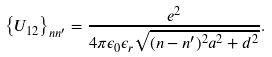<formula> <loc_0><loc_0><loc_500><loc_500>\left \{ U _ { 1 2 } \right \} _ { n n ^ { \prime } } = \frac { e ^ { 2 } } { 4 \pi \epsilon _ { 0 } \epsilon _ { r } \sqrt { ( n - n ^ { \prime } ) ^ { 2 } a ^ { 2 } + d ^ { 2 } } } .</formula> 